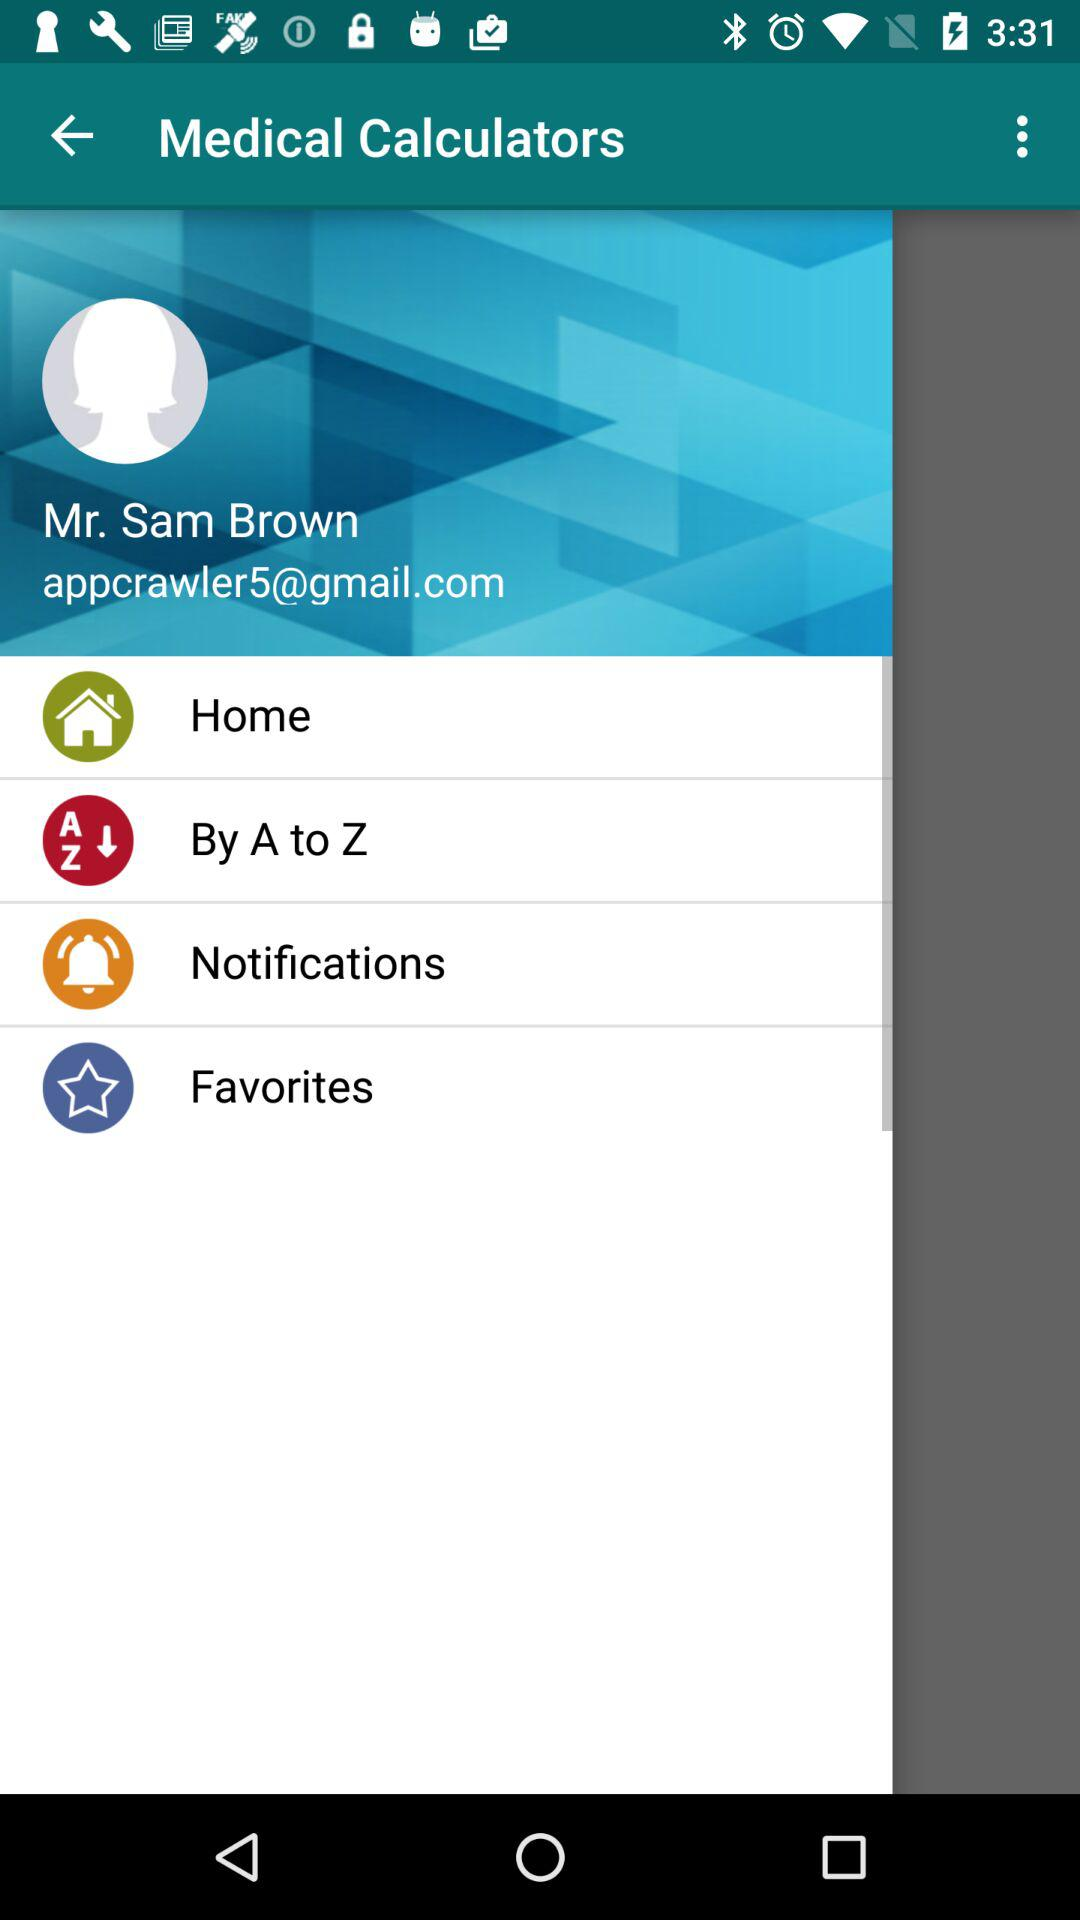What is the name of the application? The name of the application is "Medical Calculators". 